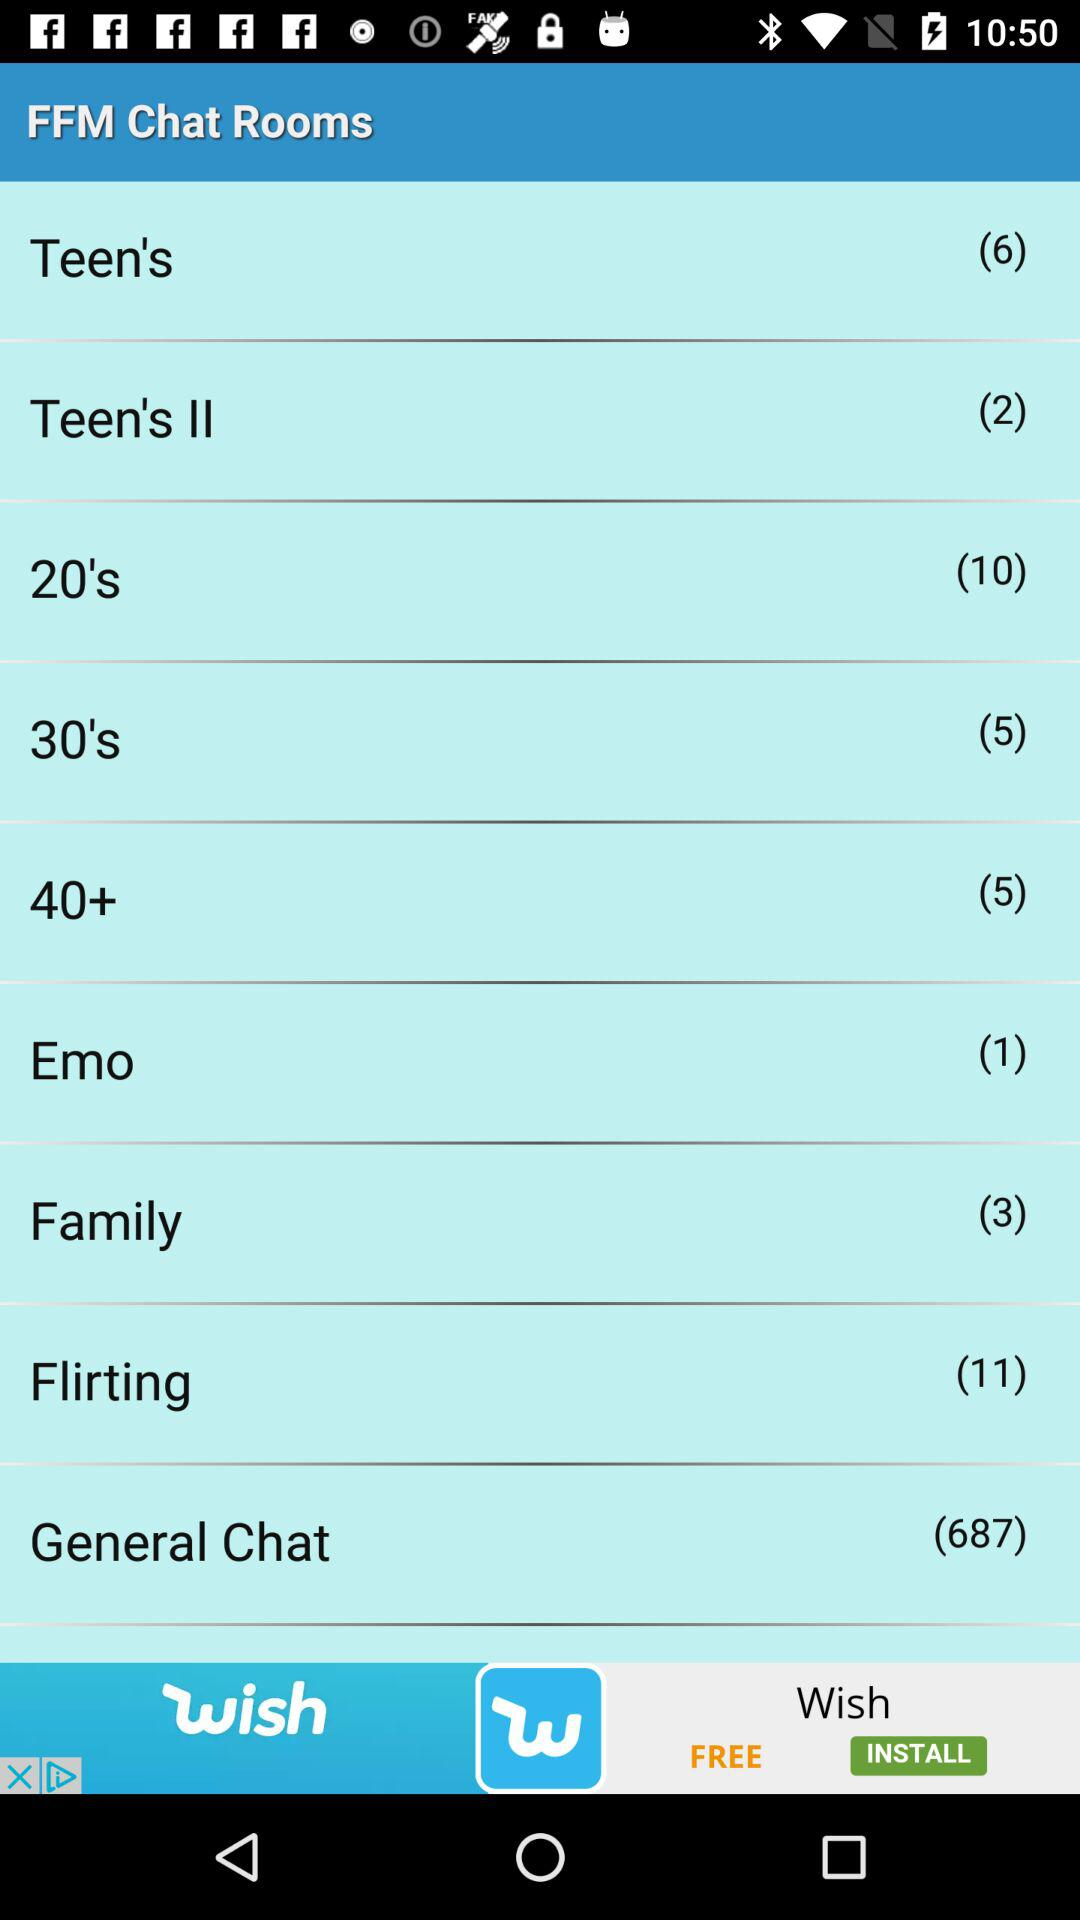Can you tell me which chat room has the highest number of participants? The 'General Chat' room has the highest number of participants, with a total of 687 people currently part of it. 